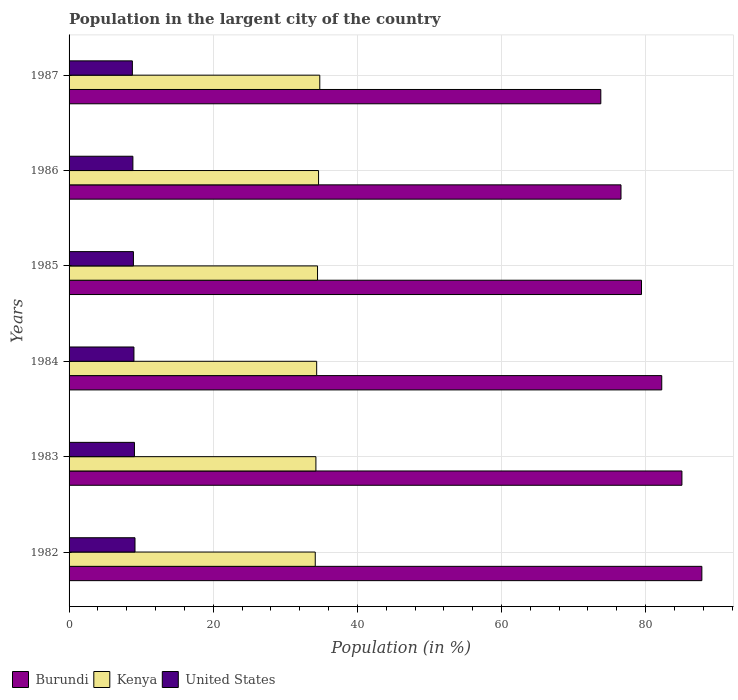How many groups of bars are there?
Your answer should be compact. 6. Are the number of bars on each tick of the Y-axis equal?
Your answer should be very brief. Yes. What is the label of the 1st group of bars from the top?
Make the answer very short. 1987. What is the percentage of population in the largent city in Burundi in 1986?
Provide a short and direct response. 76.59. Across all years, what is the maximum percentage of population in the largent city in United States?
Offer a terse response. 9.15. Across all years, what is the minimum percentage of population in the largent city in Kenya?
Keep it short and to the point. 34.16. What is the total percentage of population in the largent city in United States in the graph?
Make the answer very short. 53.79. What is the difference between the percentage of population in the largent city in Burundi in 1984 and that in 1986?
Keep it short and to the point. 5.65. What is the difference between the percentage of population in the largent city in United States in 1983 and the percentage of population in the largent city in Burundi in 1984?
Your answer should be very brief. -73.17. What is the average percentage of population in the largent city in United States per year?
Ensure brevity in your answer.  8.96. In the year 1982, what is the difference between the percentage of population in the largent city in Kenya and percentage of population in the largent city in Burundi?
Give a very brief answer. -53.64. In how many years, is the percentage of population in the largent city in Burundi greater than 48 %?
Give a very brief answer. 6. What is the ratio of the percentage of population in the largent city in Burundi in 1984 to that in 1987?
Keep it short and to the point. 1.11. Is the percentage of population in the largent city in Burundi in 1982 less than that in 1985?
Make the answer very short. No. What is the difference between the highest and the second highest percentage of population in the largent city in United States?
Provide a succinct answer. 0.08. What is the difference between the highest and the lowest percentage of population in the largent city in Burundi?
Your response must be concise. 14.02. In how many years, is the percentage of population in the largent city in United States greater than the average percentage of population in the largent city in United States taken over all years?
Keep it short and to the point. 3. Is the sum of the percentage of population in the largent city in Kenya in 1983 and 1985 greater than the maximum percentage of population in the largent city in Burundi across all years?
Your answer should be compact. No. What does the 1st bar from the bottom in 1987 represents?
Provide a short and direct response. Burundi. Is it the case that in every year, the sum of the percentage of population in the largent city in Kenya and percentage of population in the largent city in Burundi is greater than the percentage of population in the largent city in United States?
Your answer should be compact. Yes. How many years are there in the graph?
Offer a terse response. 6. What is the difference between two consecutive major ticks on the X-axis?
Offer a very short reply. 20. Are the values on the major ticks of X-axis written in scientific E-notation?
Make the answer very short. No. Does the graph contain any zero values?
Offer a terse response. No. Where does the legend appear in the graph?
Provide a short and direct response. Bottom left. How many legend labels are there?
Ensure brevity in your answer.  3. What is the title of the graph?
Ensure brevity in your answer.  Population in the largent city of the country. Does "Switzerland" appear as one of the legend labels in the graph?
Keep it short and to the point. No. What is the label or title of the X-axis?
Make the answer very short. Population (in %). What is the label or title of the Y-axis?
Make the answer very short. Years. What is the Population (in %) in Burundi in 1982?
Give a very brief answer. 87.8. What is the Population (in %) in Kenya in 1982?
Your answer should be compact. 34.16. What is the Population (in %) of United States in 1982?
Provide a succinct answer. 9.15. What is the Population (in %) of Burundi in 1983?
Provide a succinct answer. 85.04. What is the Population (in %) in Kenya in 1983?
Make the answer very short. 34.25. What is the Population (in %) in United States in 1983?
Offer a terse response. 9.07. What is the Population (in %) of Burundi in 1984?
Provide a succinct answer. 82.24. What is the Population (in %) of Kenya in 1984?
Your answer should be compact. 34.36. What is the Population (in %) in United States in 1984?
Your response must be concise. 9. What is the Population (in %) in Burundi in 1985?
Give a very brief answer. 79.43. What is the Population (in %) of Kenya in 1985?
Offer a terse response. 34.48. What is the Population (in %) in United States in 1985?
Give a very brief answer. 8.93. What is the Population (in %) of Burundi in 1986?
Give a very brief answer. 76.59. What is the Population (in %) of Kenya in 1986?
Offer a terse response. 34.62. What is the Population (in %) in United States in 1986?
Ensure brevity in your answer.  8.86. What is the Population (in %) of Burundi in 1987?
Give a very brief answer. 73.78. What is the Population (in %) of Kenya in 1987?
Offer a very short reply. 34.79. What is the Population (in %) of United States in 1987?
Offer a terse response. 8.78. Across all years, what is the maximum Population (in %) of Burundi?
Make the answer very short. 87.8. Across all years, what is the maximum Population (in %) of Kenya?
Keep it short and to the point. 34.79. Across all years, what is the maximum Population (in %) of United States?
Offer a very short reply. 9.15. Across all years, what is the minimum Population (in %) in Burundi?
Ensure brevity in your answer.  73.78. Across all years, what is the minimum Population (in %) of Kenya?
Give a very brief answer. 34.16. Across all years, what is the minimum Population (in %) in United States?
Your answer should be compact. 8.78. What is the total Population (in %) of Burundi in the graph?
Offer a terse response. 484.88. What is the total Population (in %) in Kenya in the graph?
Your answer should be compact. 206.65. What is the total Population (in %) of United States in the graph?
Give a very brief answer. 53.79. What is the difference between the Population (in %) in Burundi in 1982 and that in 1983?
Ensure brevity in your answer.  2.76. What is the difference between the Population (in %) in Kenya in 1982 and that in 1983?
Provide a succinct answer. -0.09. What is the difference between the Population (in %) of United States in 1982 and that in 1983?
Keep it short and to the point. 0.08. What is the difference between the Population (in %) of Burundi in 1982 and that in 1984?
Provide a succinct answer. 5.57. What is the difference between the Population (in %) in Kenya in 1982 and that in 1984?
Give a very brief answer. -0.2. What is the difference between the Population (in %) of United States in 1982 and that in 1984?
Ensure brevity in your answer.  0.15. What is the difference between the Population (in %) of Burundi in 1982 and that in 1985?
Ensure brevity in your answer.  8.38. What is the difference between the Population (in %) in Kenya in 1982 and that in 1985?
Give a very brief answer. -0.32. What is the difference between the Population (in %) in United States in 1982 and that in 1985?
Provide a short and direct response. 0.22. What is the difference between the Population (in %) of Burundi in 1982 and that in 1986?
Provide a succinct answer. 11.22. What is the difference between the Population (in %) in Kenya in 1982 and that in 1986?
Offer a very short reply. -0.46. What is the difference between the Population (in %) of United States in 1982 and that in 1986?
Ensure brevity in your answer.  0.29. What is the difference between the Population (in %) in Burundi in 1982 and that in 1987?
Provide a short and direct response. 14.02. What is the difference between the Population (in %) in Kenya in 1982 and that in 1987?
Make the answer very short. -0.63. What is the difference between the Population (in %) in United States in 1982 and that in 1987?
Provide a short and direct response. 0.36. What is the difference between the Population (in %) in Burundi in 1983 and that in 1984?
Provide a short and direct response. 2.8. What is the difference between the Population (in %) of Kenya in 1983 and that in 1984?
Offer a terse response. -0.11. What is the difference between the Population (in %) of United States in 1983 and that in 1984?
Provide a short and direct response. 0.07. What is the difference between the Population (in %) in Burundi in 1983 and that in 1985?
Provide a short and direct response. 5.61. What is the difference between the Population (in %) of Kenya in 1983 and that in 1985?
Offer a terse response. -0.23. What is the difference between the Population (in %) of United States in 1983 and that in 1985?
Keep it short and to the point. 0.14. What is the difference between the Population (in %) in Burundi in 1983 and that in 1986?
Give a very brief answer. 8.45. What is the difference between the Population (in %) in Kenya in 1983 and that in 1986?
Provide a short and direct response. -0.37. What is the difference between the Population (in %) of United States in 1983 and that in 1986?
Offer a very short reply. 0.22. What is the difference between the Population (in %) in Burundi in 1983 and that in 1987?
Give a very brief answer. 11.26. What is the difference between the Population (in %) in Kenya in 1983 and that in 1987?
Offer a terse response. -0.54. What is the difference between the Population (in %) of United States in 1983 and that in 1987?
Provide a succinct answer. 0.29. What is the difference between the Population (in %) of Burundi in 1984 and that in 1985?
Ensure brevity in your answer.  2.81. What is the difference between the Population (in %) in Kenya in 1984 and that in 1985?
Give a very brief answer. -0.12. What is the difference between the Population (in %) of United States in 1984 and that in 1985?
Provide a short and direct response. 0.07. What is the difference between the Population (in %) in Burundi in 1984 and that in 1986?
Give a very brief answer. 5.65. What is the difference between the Population (in %) of Kenya in 1984 and that in 1986?
Provide a short and direct response. -0.26. What is the difference between the Population (in %) of United States in 1984 and that in 1986?
Your answer should be very brief. 0.15. What is the difference between the Population (in %) in Burundi in 1984 and that in 1987?
Provide a succinct answer. 8.46. What is the difference between the Population (in %) of Kenya in 1984 and that in 1987?
Provide a succinct answer. -0.43. What is the difference between the Population (in %) of United States in 1984 and that in 1987?
Offer a very short reply. 0.22. What is the difference between the Population (in %) in Burundi in 1985 and that in 1986?
Provide a short and direct response. 2.84. What is the difference between the Population (in %) in Kenya in 1985 and that in 1986?
Keep it short and to the point. -0.14. What is the difference between the Population (in %) in United States in 1985 and that in 1986?
Your response must be concise. 0.07. What is the difference between the Population (in %) in Burundi in 1985 and that in 1987?
Provide a short and direct response. 5.65. What is the difference between the Population (in %) of Kenya in 1985 and that in 1987?
Offer a terse response. -0.31. What is the difference between the Population (in %) in United States in 1985 and that in 1987?
Keep it short and to the point. 0.15. What is the difference between the Population (in %) in Burundi in 1986 and that in 1987?
Your answer should be very brief. 2.8. What is the difference between the Population (in %) of Kenya in 1986 and that in 1987?
Give a very brief answer. -0.17. What is the difference between the Population (in %) in United States in 1986 and that in 1987?
Offer a very short reply. 0.07. What is the difference between the Population (in %) of Burundi in 1982 and the Population (in %) of Kenya in 1983?
Your answer should be very brief. 53.55. What is the difference between the Population (in %) in Burundi in 1982 and the Population (in %) in United States in 1983?
Offer a terse response. 78.73. What is the difference between the Population (in %) in Kenya in 1982 and the Population (in %) in United States in 1983?
Provide a short and direct response. 25.09. What is the difference between the Population (in %) of Burundi in 1982 and the Population (in %) of Kenya in 1984?
Offer a very short reply. 53.45. What is the difference between the Population (in %) of Burundi in 1982 and the Population (in %) of United States in 1984?
Make the answer very short. 78.8. What is the difference between the Population (in %) of Kenya in 1982 and the Population (in %) of United States in 1984?
Make the answer very short. 25.16. What is the difference between the Population (in %) in Burundi in 1982 and the Population (in %) in Kenya in 1985?
Offer a terse response. 53.33. What is the difference between the Population (in %) of Burundi in 1982 and the Population (in %) of United States in 1985?
Make the answer very short. 78.87. What is the difference between the Population (in %) of Kenya in 1982 and the Population (in %) of United States in 1985?
Make the answer very short. 25.23. What is the difference between the Population (in %) in Burundi in 1982 and the Population (in %) in Kenya in 1986?
Keep it short and to the point. 53.18. What is the difference between the Population (in %) of Burundi in 1982 and the Population (in %) of United States in 1986?
Your response must be concise. 78.95. What is the difference between the Population (in %) in Kenya in 1982 and the Population (in %) in United States in 1986?
Your answer should be very brief. 25.3. What is the difference between the Population (in %) in Burundi in 1982 and the Population (in %) in Kenya in 1987?
Your answer should be compact. 53.02. What is the difference between the Population (in %) in Burundi in 1982 and the Population (in %) in United States in 1987?
Provide a succinct answer. 79.02. What is the difference between the Population (in %) of Kenya in 1982 and the Population (in %) of United States in 1987?
Provide a short and direct response. 25.38. What is the difference between the Population (in %) of Burundi in 1983 and the Population (in %) of Kenya in 1984?
Provide a succinct answer. 50.68. What is the difference between the Population (in %) of Burundi in 1983 and the Population (in %) of United States in 1984?
Ensure brevity in your answer.  76.04. What is the difference between the Population (in %) of Kenya in 1983 and the Population (in %) of United States in 1984?
Provide a short and direct response. 25.25. What is the difference between the Population (in %) of Burundi in 1983 and the Population (in %) of Kenya in 1985?
Ensure brevity in your answer.  50.56. What is the difference between the Population (in %) of Burundi in 1983 and the Population (in %) of United States in 1985?
Provide a succinct answer. 76.11. What is the difference between the Population (in %) of Kenya in 1983 and the Population (in %) of United States in 1985?
Provide a short and direct response. 25.32. What is the difference between the Population (in %) in Burundi in 1983 and the Population (in %) in Kenya in 1986?
Your answer should be compact. 50.42. What is the difference between the Population (in %) in Burundi in 1983 and the Population (in %) in United States in 1986?
Your answer should be very brief. 76.18. What is the difference between the Population (in %) of Kenya in 1983 and the Population (in %) of United States in 1986?
Provide a short and direct response. 25.4. What is the difference between the Population (in %) in Burundi in 1983 and the Population (in %) in Kenya in 1987?
Give a very brief answer. 50.25. What is the difference between the Population (in %) in Burundi in 1983 and the Population (in %) in United States in 1987?
Your answer should be compact. 76.26. What is the difference between the Population (in %) of Kenya in 1983 and the Population (in %) of United States in 1987?
Offer a very short reply. 25.47. What is the difference between the Population (in %) in Burundi in 1984 and the Population (in %) in Kenya in 1985?
Ensure brevity in your answer.  47.76. What is the difference between the Population (in %) of Burundi in 1984 and the Population (in %) of United States in 1985?
Your answer should be compact. 73.31. What is the difference between the Population (in %) in Kenya in 1984 and the Population (in %) in United States in 1985?
Provide a succinct answer. 25.43. What is the difference between the Population (in %) of Burundi in 1984 and the Population (in %) of Kenya in 1986?
Your answer should be compact. 47.62. What is the difference between the Population (in %) in Burundi in 1984 and the Population (in %) in United States in 1986?
Provide a short and direct response. 73.38. What is the difference between the Population (in %) in Kenya in 1984 and the Population (in %) in United States in 1986?
Ensure brevity in your answer.  25.5. What is the difference between the Population (in %) of Burundi in 1984 and the Population (in %) of Kenya in 1987?
Ensure brevity in your answer.  47.45. What is the difference between the Population (in %) in Burundi in 1984 and the Population (in %) in United States in 1987?
Your response must be concise. 73.45. What is the difference between the Population (in %) of Kenya in 1984 and the Population (in %) of United States in 1987?
Make the answer very short. 25.57. What is the difference between the Population (in %) of Burundi in 1985 and the Population (in %) of Kenya in 1986?
Your response must be concise. 44.81. What is the difference between the Population (in %) of Burundi in 1985 and the Population (in %) of United States in 1986?
Keep it short and to the point. 70.57. What is the difference between the Population (in %) in Kenya in 1985 and the Population (in %) in United States in 1986?
Your answer should be compact. 25.62. What is the difference between the Population (in %) in Burundi in 1985 and the Population (in %) in Kenya in 1987?
Offer a very short reply. 44.64. What is the difference between the Population (in %) of Burundi in 1985 and the Population (in %) of United States in 1987?
Provide a succinct answer. 70.65. What is the difference between the Population (in %) in Kenya in 1985 and the Population (in %) in United States in 1987?
Provide a succinct answer. 25.69. What is the difference between the Population (in %) in Burundi in 1986 and the Population (in %) in Kenya in 1987?
Provide a succinct answer. 41.8. What is the difference between the Population (in %) of Burundi in 1986 and the Population (in %) of United States in 1987?
Offer a terse response. 67.8. What is the difference between the Population (in %) in Kenya in 1986 and the Population (in %) in United States in 1987?
Make the answer very short. 25.84. What is the average Population (in %) of Burundi per year?
Your response must be concise. 80.81. What is the average Population (in %) in Kenya per year?
Your answer should be very brief. 34.44. What is the average Population (in %) of United States per year?
Your answer should be very brief. 8.96. In the year 1982, what is the difference between the Population (in %) of Burundi and Population (in %) of Kenya?
Your answer should be compact. 53.64. In the year 1982, what is the difference between the Population (in %) of Burundi and Population (in %) of United States?
Keep it short and to the point. 78.66. In the year 1982, what is the difference between the Population (in %) in Kenya and Population (in %) in United States?
Provide a short and direct response. 25.01. In the year 1983, what is the difference between the Population (in %) of Burundi and Population (in %) of Kenya?
Provide a short and direct response. 50.79. In the year 1983, what is the difference between the Population (in %) of Burundi and Population (in %) of United States?
Give a very brief answer. 75.97. In the year 1983, what is the difference between the Population (in %) in Kenya and Population (in %) in United States?
Ensure brevity in your answer.  25.18. In the year 1984, what is the difference between the Population (in %) in Burundi and Population (in %) in Kenya?
Your answer should be very brief. 47.88. In the year 1984, what is the difference between the Population (in %) in Burundi and Population (in %) in United States?
Offer a very short reply. 73.24. In the year 1984, what is the difference between the Population (in %) of Kenya and Population (in %) of United States?
Your response must be concise. 25.36. In the year 1985, what is the difference between the Population (in %) in Burundi and Population (in %) in Kenya?
Offer a terse response. 44.95. In the year 1985, what is the difference between the Population (in %) of Burundi and Population (in %) of United States?
Ensure brevity in your answer.  70.5. In the year 1985, what is the difference between the Population (in %) in Kenya and Population (in %) in United States?
Keep it short and to the point. 25.55. In the year 1986, what is the difference between the Population (in %) in Burundi and Population (in %) in Kenya?
Your response must be concise. 41.97. In the year 1986, what is the difference between the Population (in %) of Burundi and Population (in %) of United States?
Your answer should be very brief. 67.73. In the year 1986, what is the difference between the Population (in %) in Kenya and Population (in %) in United States?
Offer a terse response. 25.77. In the year 1987, what is the difference between the Population (in %) in Burundi and Population (in %) in Kenya?
Your answer should be very brief. 39. In the year 1987, what is the difference between the Population (in %) in Burundi and Population (in %) in United States?
Ensure brevity in your answer.  65. In the year 1987, what is the difference between the Population (in %) of Kenya and Population (in %) of United States?
Make the answer very short. 26. What is the ratio of the Population (in %) in Burundi in 1982 to that in 1983?
Give a very brief answer. 1.03. What is the ratio of the Population (in %) of United States in 1982 to that in 1983?
Provide a succinct answer. 1.01. What is the ratio of the Population (in %) of Burundi in 1982 to that in 1984?
Your response must be concise. 1.07. What is the ratio of the Population (in %) of United States in 1982 to that in 1984?
Your answer should be very brief. 1.02. What is the ratio of the Population (in %) in Burundi in 1982 to that in 1985?
Provide a short and direct response. 1.11. What is the ratio of the Population (in %) of Kenya in 1982 to that in 1985?
Give a very brief answer. 0.99. What is the ratio of the Population (in %) of United States in 1982 to that in 1985?
Your answer should be very brief. 1.02. What is the ratio of the Population (in %) of Burundi in 1982 to that in 1986?
Your answer should be compact. 1.15. What is the ratio of the Population (in %) in Kenya in 1982 to that in 1986?
Your response must be concise. 0.99. What is the ratio of the Population (in %) of United States in 1982 to that in 1986?
Offer a terse response. 1.03. What is the ratio of the Population (in %) in Burundi in 1982 to that in 1987?
Keep it short and to the point. 1.19. What is the ratio of the Population (in %) in Kenya in 1982 to that in 1987?
Offer a terse response. 0.98. What is the ratio of the Population (in %) in United States in 1982 to that in 1987?
Give a very brief answer. 1.04. What is the ratio of the Population (in %) of Burundi in 1983 to that in 1984?
Provide a succinct answer. 1.03. What is the ratio of the Population (in %) of Burundi in 1983 to that in 1985?
Make the answer very short. 1.07. What is the ratio of the Population (in %) in Kenya in 1983 to that in 1985?
Your response must be concise. 0.99. What is the ratio of the Population (in %) of United States in 1983 to that in 1985?
Your answer should be compact. 1.02. What is the ratio of the Population (in %) in Burundi in 1983 to that in 1986?
Provide a succinct answer. 1.11. What is the ratio of the Population (in %) of Kenya in 1983 to that in 1986?
Give a very brief answer. 0.99. What is the ratio of the Population (in %) of United States in 1983 to that in 1986?
Give a very brief answer. 1.02. What is the ratio of the Population (in %) of Burundi in 1983 to that in 1987?
Give a very brief answer. 1.15. What is the ratio of the Population (in %) in Kenya in 1983 to that in 1987?
Provide a short and direct response. 0.98. What is the ratio of the Population (in %) in United States in 1983 to that in 1987?
Your answer should be very brief. 1.03. What is the ratio of the Population (in %) in Burundi in 1984 to that in 1985?
Your response must be concise. 1.04. What is the ratio of the Population (in %) of United States in 1984 to that in 1985?
Ensure brevity in your answer.  1.01. What is the ratio of the Population (in %) in Burundi in 1984 to that in 1986?
Your answer should be very brief. 1.07. What is the ratio of the Population (in %) of United States in 1984 to that in 1986?
Keep it short and to the point. 1.02. What is the ratio of the Population (in %) in Burundi in 1984 to that in 1987?
Keep it short and to the point. 1.11. What is the ratio of the Population (in %) of Kenya in 1984 to that in 1987?
Ensure brevity in your answer.  0.99. What is the ratio of the Population (in %) in United States in 1984 to that in 1987?
Your response must be concise. 1.02. What is the ratio of the Population (in %) in Burundi in 1985 to that in 1986?
Ensure brevity in your answer.  1.04. What is the ratio of the Population (in %) of Kenya in 1985 to that in 1986?
Ensure brevity in your answer.  1. What is the ratio of the Population (in %) of United States in 1985 to that in 1986?
Ensure brevity in your answer.  1.01. What is the ratio of the Population (in %) in Burundi in 1985 to that in 1987?
Keep it short and to the point. 1.08. What is the ratio of the Population (in %) in Kenya in 1985 to that in 1987?
Make the answer very short. 0.99. What is the ratio of the Population (in %) in United States in 1985 to that in 1987?
Make the answer very short. 1.02. What is the ratio of the Population (in %) of Burundi in 1986 to that in 1987?
Provide a short and direct response. 1.04. What is the ratio of the Population (in %) in Kenya in 1986 to that in 1987?
Keep it short and to the point. 1. What is the difference between the highest and the second highest Population (in %) in Burundi?
Provide a succinct answer. 2.76. What is the difference between the highest and the second highest Population (in %) of Kenya?
Your response must be concise. 0.17. What is the difference between the highest and the second highest Population (in %) of United States?
Your answer should be compact. 0.08. What is the difference between the highest and the lowest Population (in %) in Burundi?
Provide a succinct answer. 14.02. What is the difference between the highest and the lowest Population (in %) of Kenya?
Offer a terse response. 0.63. What is the difference between the highest and the lowest Population (in %) of United States?
Make the answer very short. 0.36. 